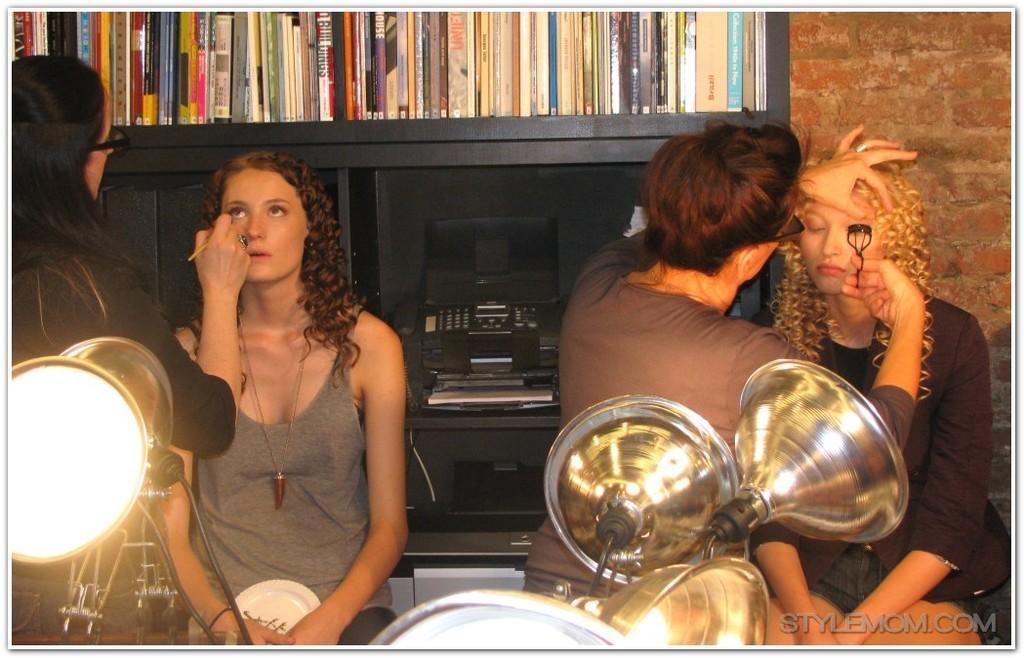Could you give a brief overview of what you see in this image? In this picture we can see four persons here, there are some lights in the front, we can see a rack, there are some books on the rack, we can see a telephone here, in the background there is a wall, at the right bottom we can see some text. 